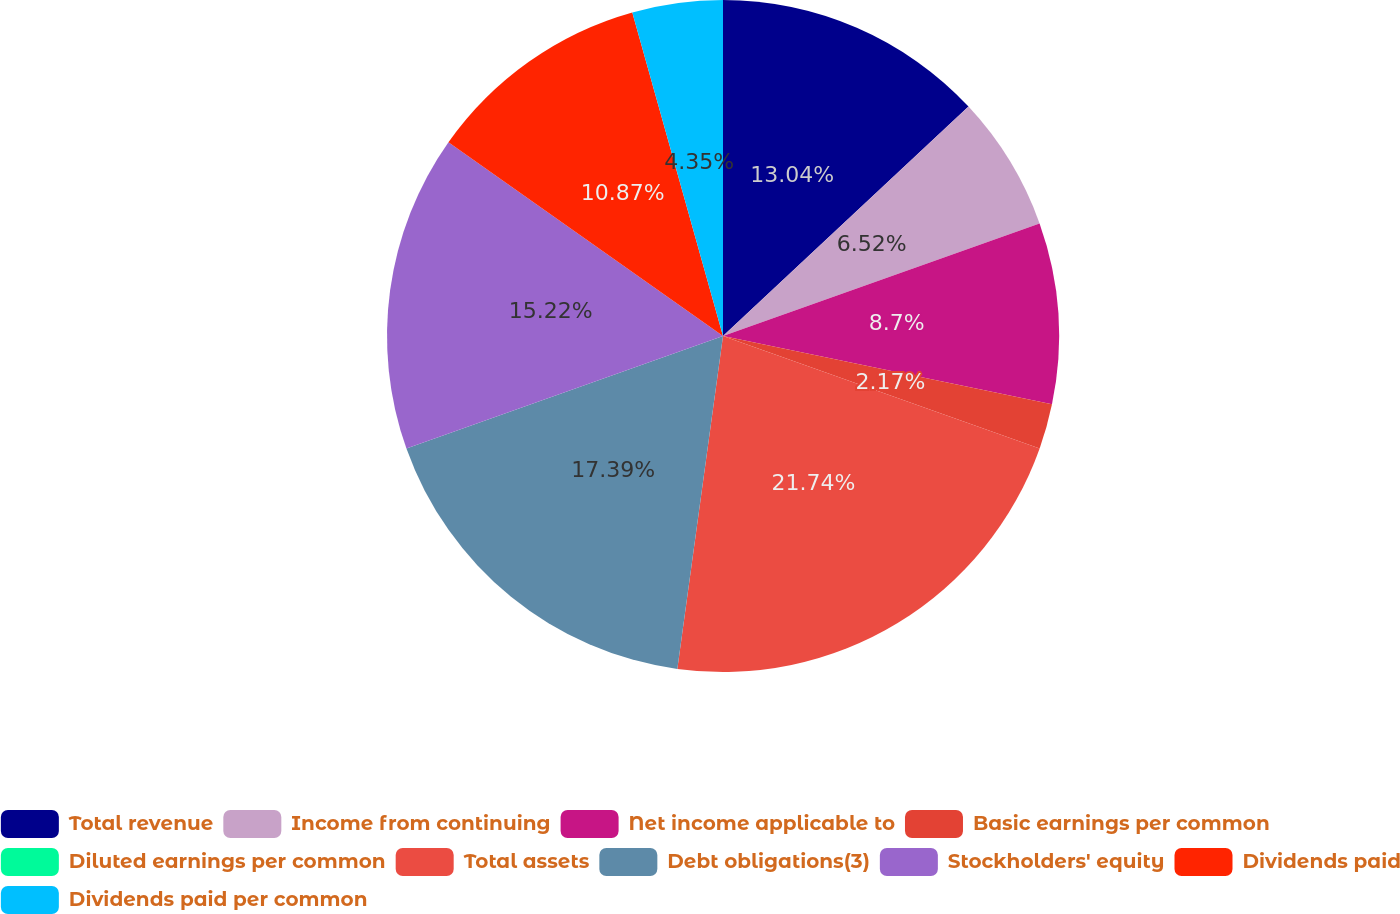Convert chart. <chart><loc_0><loc_0><loc_500><loc_500><pie_chart><fcel>Total revenue<fcel>Income from continuing<fcel>Net income applicable to<fcel>Basic earnings per common<fcel>Diluted earnings per common<fcel>Total assets<fcel>Debt obligations(3)<fcel>Stockholders' equity<fcel>Dividends paid<fcel>Dividends paid per common<nl><fcel>13.04%<fcel>6.52%<fcel>8.7%<fcel>2.17%<fcel>0.0%<fcel>21.74%<fcel>17.39%<fcel>15.22%<fcel>10.87%<fcel>4.35%<nl></chart> 